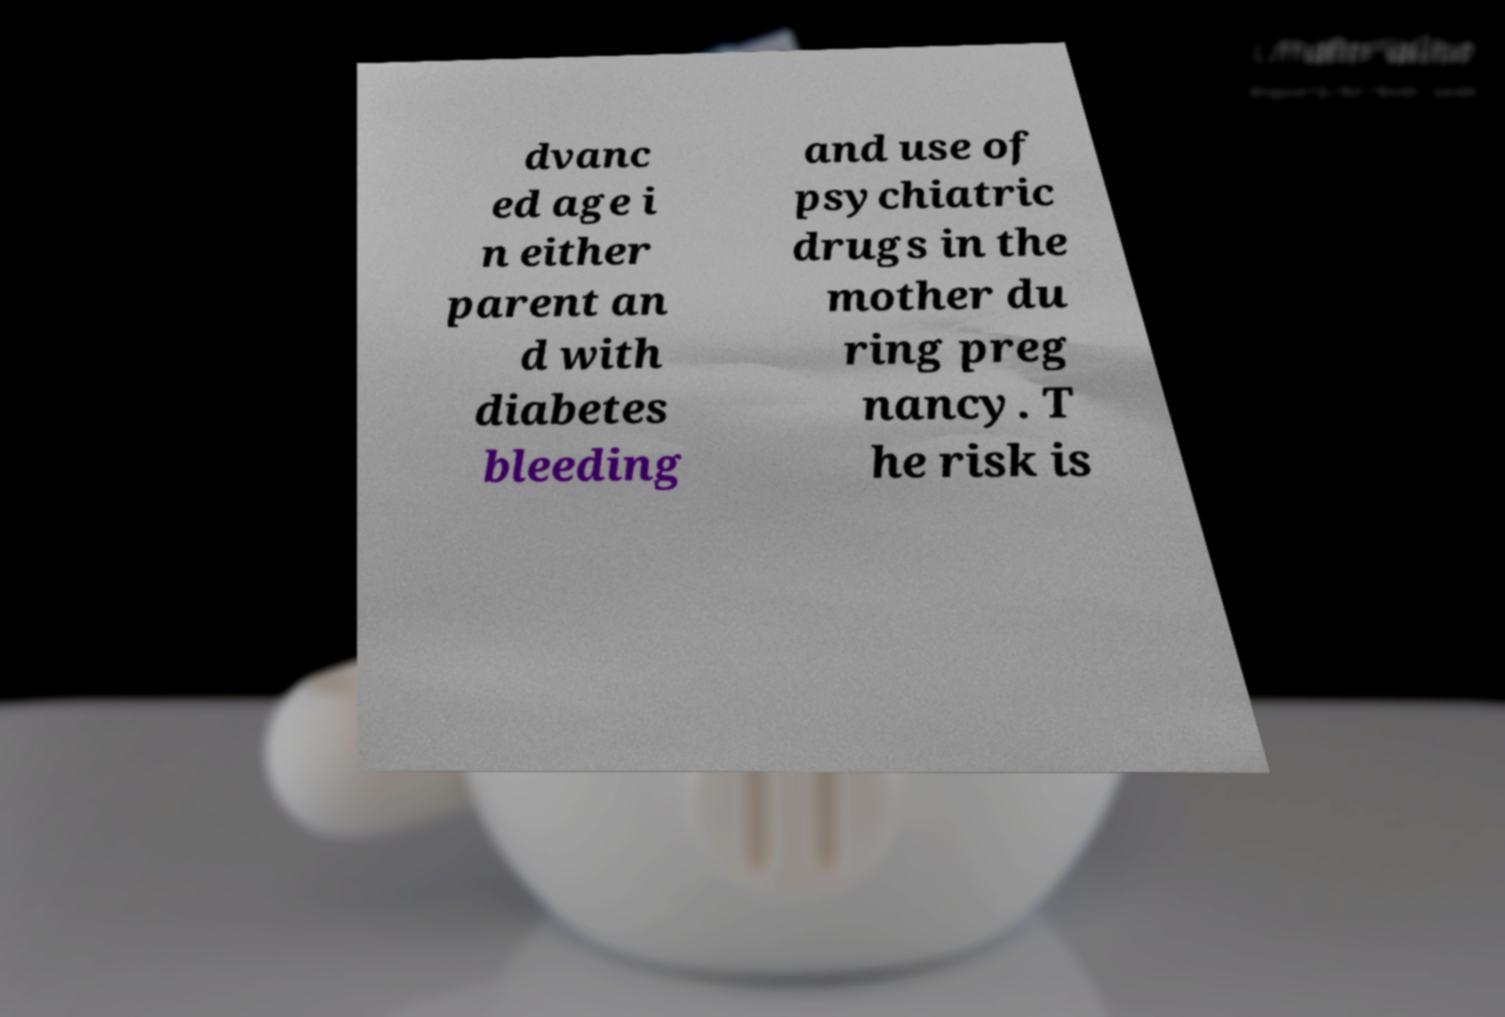Please read and relay the text visible in this image. What does it say? dvanc ed age i n either parent an d with diabetes bleeding and use of psychiatric drugs in the mother du ring preg nancy. T he risk is 